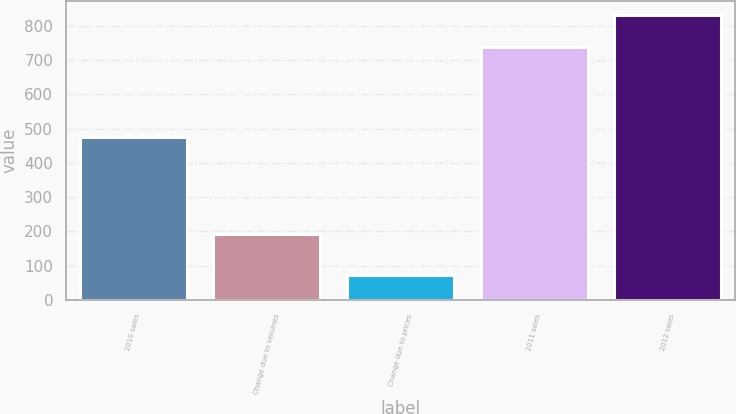Convert chart. <chart><loc_0><loc_0><loc_500><loc_500><bar_chart><fcel>2010 sales<fcel>Change due to volumes<fcel>Change due to prices<fcel>2011 sales<fcel>2012 sales<nl><fcel>474<fcel>193<fcel>72<fcel>739<fcel>831<nl></chart> 